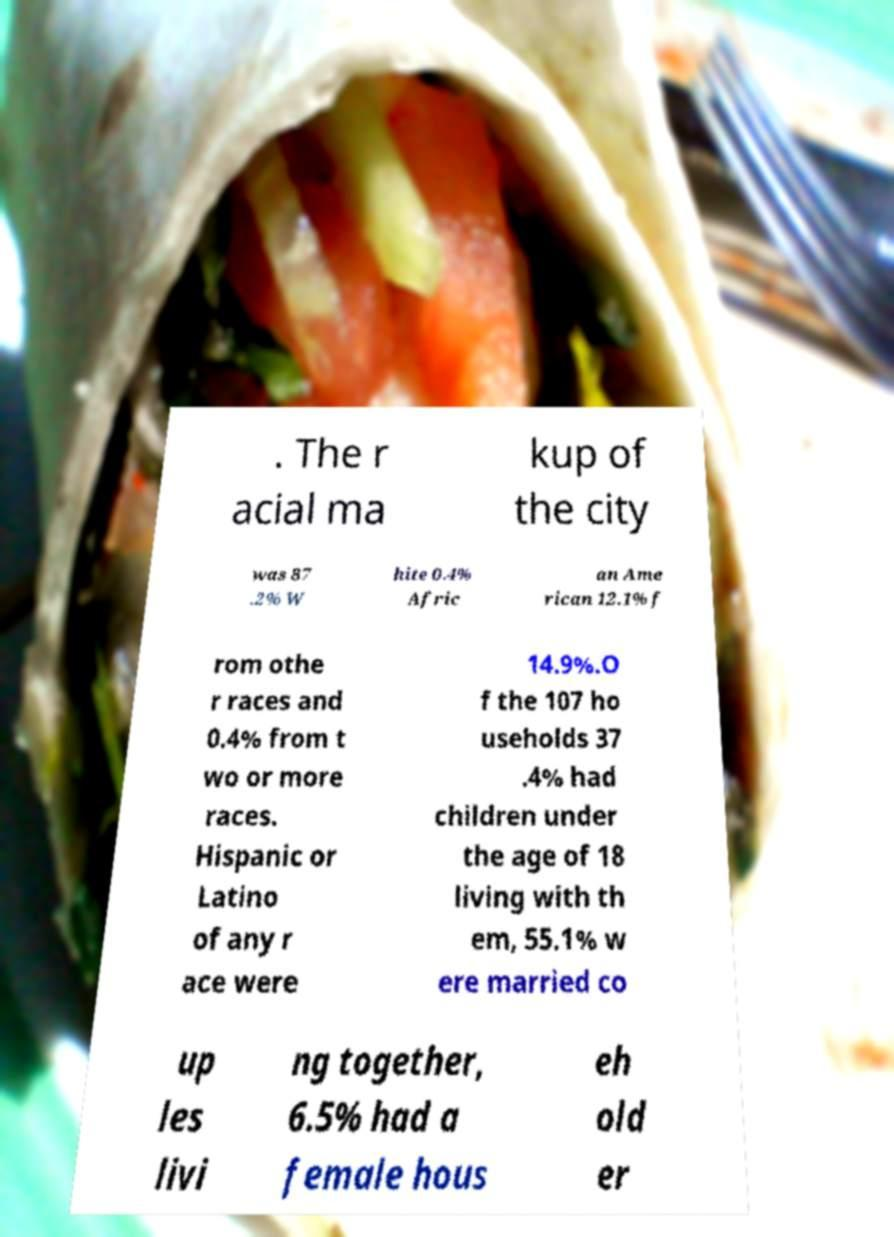For documentation purposes, I need the text within this image transcribed. Could you provide that? . The r acial ma kup of the city was 87 .2% W hite 0.4% Afric an Ame rican 12.1% f rom othe r races and 0.4% from t wo or more races. Hispanic or Latino of any r ace were 14.9%.O f the 107 ho useholds 37 .4% had children under the age of 18 living with th em, 55.1% w ere married co up les livi ng together, 6.5% had a female hous eh old er 